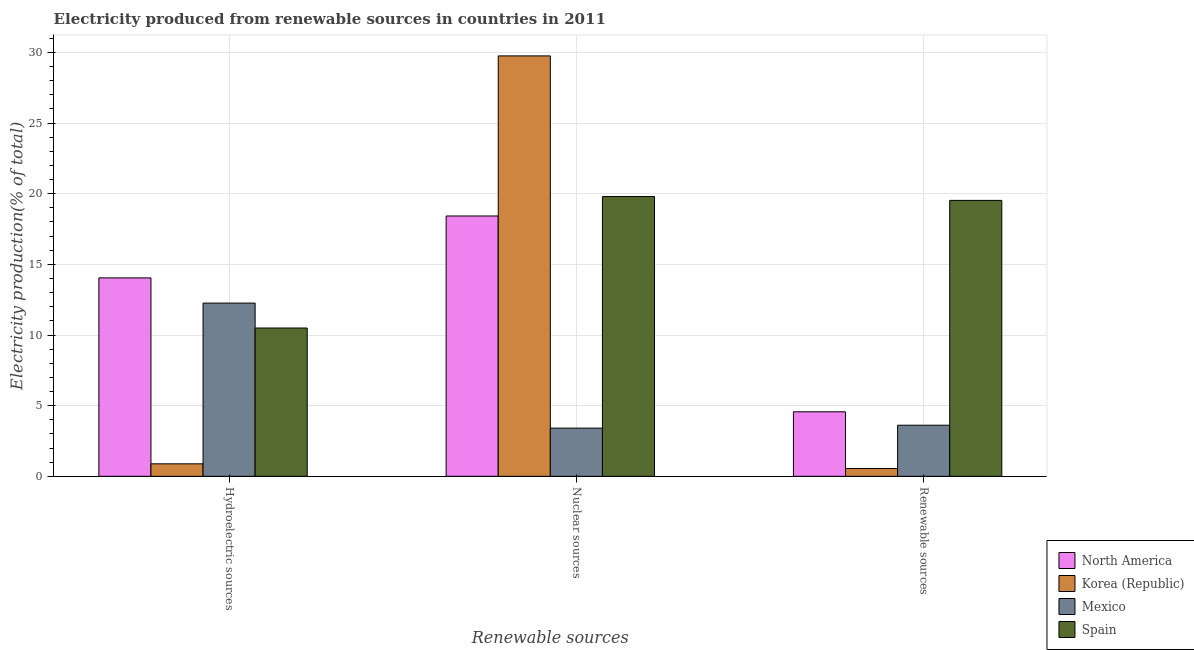Are the number of bars per tick equal to the number of legend labels?
Offer a terse response. Yes. How many bars are there on the 2nd tick from the right?
Give a very brief answer. 4. What is the label of the 1st group of bars from the left?
Provide a short and direct response. Hydroelectric sources. What is the percentage of electricity produced by hydroelectric sources in North America?
Offer a very short reply. 14.04. Across all countries, what is the maximum percentage of electricity produced by renewable sources?
Your response must be concise. 19.53. Across all countries, what is the minimum percentage of electricity produced by nuclear sources?
Your answer should be very brief. 3.41. In which country was the percentage of electricity produced by hydroelectric sources maximum?
Your answer should be compact. North America. In which country was the percentage of electricity produced by nuclear sources minimum?
Your answer should be very brief. Mexico. What is the total percentage of electricity produced by renewable sources in the graph?
Your answer should be very brief. 28.26. What is the difference between the percentage of electricity produced by nuclear sources in North America and that in Korea (Republic)?
Make the answer very short. -11.33. What is the difference between the percentage of electricity produced by renewable sources in Spain and the percentage of electricity produced by nuclear sources in North America?
Make the answer very short. 1.1. What is the average percentage of electricity produced by renewable sources per country?
Your response must be concise. 7.07. What is the difference between the percentage of electricity produced by renewable sources and percentage of electricity produced by nuclear sources in Spain?
Offer a terse response. -0.27. What is the ratio of the percentage of electricity produced by hydroelectric sources in North America to that in Spain?
Provide a short and direct response. 1.34. Is the percentage of electricity produced by hydroelectric sources in Mexico less than that in Korea (Republic)?
Ensure brevity in your answer.  No. Is the difference between the percentage of electricity produced by nuclear sources in North America and Spain greater than the difference between the percentage of electricity produced by hydroelectric sources in North America and Spain?
Your answer should be compact. No. What is the difference between the highest and the second highest percentage of electricity produced by renewable sources?
Provide a short and direct response. 14.96. What is the difference between the highest and the lowest percentage of electricity produced by hydroelectric sources?
Ensure brevity in your answer.  13.16. What does the 2nd bar from the left in Nuclear sources represents?
Make the answer very short. Korea (Republic). What is the difference between two consecutive major ticks on the Y-axis?
Your response must be concise. 5. Are the values on the major ticks of Y-axis written in scientific E-notation?
Your answer should be very brief. No. How many legend labels are there?
Give a very brief answer. 4. What is the title of the graph?
Offer a terse response. Electricity produced from renewable sources in countries in 2011. What is the label or title of the X-axis?
Provide a short and direct response. Renewable sources. What is the Electricity production(% of total) in North America in Hydroelectric sources?
Offer a very short reply. 14.04. What is the Electricity production(% of total) of Korea (Republic) in Hydroelectric sources?
Your answer should be compact. 0.88. What is the Electricity production(% of total) in Mexico in Hydroelectric sources?
Your answer should be compact. 12.26. What is the Electricity production(% of total) of Spain in Hydroelectric sources?
Your answer should be compact. 10.49. What is the Electricity production(% of total) in North America in Nuclear sources?
Give a very brief answer. 18.42. What is the Electricity production(% of total) of Korea (Republic) in Nuclear sources?
Offer a terse response. 29.75. What is the Electricity production(% of total) in Mexico in Nuclear sources?
Keep it short and to the point. 3.41. What is the Electricity production(% of total) of Spain in Nuclear sources?
Your response must be concise. 19.8. What is the Electricity production(% of total) of North America in Renewable sources?
Provide a short and direct response. 4.56. What is the Electricity production(% of total) in Korea (Republic) in Renewable sources?
Ensure brevity in your answer.  0.55. What is the Electricity production(% of total) of Mexico in Renewable sources?
Your answer should be very brief. 3.62. What is the Electricity production(% of total) of Spain in Renewable sources?
Make the answer very short. 19.53. Across all Renewable sources, what is the maximum Electricity production(% of total) in North America?
Ensure brevity in your answer.  18.42. Across all Renewable sources, what is the maximum Electricity production(% of total) in Korea (Republic)?
Offer a terse response. 29.75. Across all Renewable sources, what is the maximum Electricity production(% of total) of Mexico?
Provide a short and direct response. 12.26. Across all Renewable sources, what is the maximum Electricity production(% of total) of Spain?
Offer a terse response. 19.8. Across all Renewable sources, what is the minimum Electricity production(% of total) in North America?
Offer a terse response. 4.56. Across all Renewable sources, what is the minimum Electricity production(% of total) of Korea (Republic)?
Offer a very short reply. 0.55. Across all Renewable sources, what is the minimum Electricity production(% of total) in Mexico?
Provide a succinct answer. 3.41. Across all Renewable sources, what is the minimum Electricity production(% of total) in Spain?
Give a very brief answer. 10.49. What is the total Electricity production(% of total) of North America in the graph?
Give a very brief answer. 37.03. What is the total Electricity production(% of total) of Korea (Republic) in the graph?
Give a very brief answer. 31.19. What is the total Electricity production(% of total) of Mexico in the graph?
Give a very brief answer. 19.29. What is the total Electricity production(% of total) in Spain in the graph?
Keep it short and to the point. 49.82. What is the difference between the Electricity production(% of total) in North America in Hydroelectric sources and that in Nuclear sources?
Make the answer very short. -4.38. What is the difference between the Electricity production(% of total) of Korea (Republic) in Hydroelectric sources and that in Nuclear sources?
Your response must be concise. -28.87. What is the difference between the Electricity production(% of total) of Mexico in Hydroelectric sources and that in Nuclear sources?
Ensure brevity in your answer.  8.85. What is the difference between the Electricity production(% of total) in Spain in Hydroelectric sources and that in Nuclear sources?
Make the answer very short. -9.3. What is the difference between the Electricity production(% of total) in North America in Hydroelectric sources and that in Renewable sources?
Make the answer very short. 9.48. What is the difference between the Electricity production(% of total) in Korea (Republic) in Hydroelectric sources and that in Renewable sources?
Offer a very short reply. 0.33. What is the difference between the Electricity production(% of total) of Mexico in Hydroelectric sources and that in Renewable sources?
Provide a short and direct response. 8.64. What is the difference between the Electricity production(% of total) of Spain in Hydroelectric sources and that in Renewable sources?
Ensure brevity in your answer.  -9.03. What is the difference between the Electricity production(% of total) in North America in Nuclear sources and that in Renewable sources?
Offer a terse response. 13.86. What is the difference between the Electricity production(% of total) of Korea (Republic) in Nuclear sources and that in Renewable sources?
Make the answer very short. 29.2. What is the difference between the Electricity production(% of total) of Mexico in Nuclear sources and that in Renewable sources?
Provide a short and direct response. -0.21. What is the difference between the Electricity production(% of total) of Spain in Nuclear sources and that in Renewable sources?
Give a very brief answer. 0.27. What is the difference between the Electricity production(% of total) in North America in Hydroelectric sources and the Electricity production(% of total) in Korea (Republic) in Nuclear sources?
Offer a terse response. -15.71. What is the difference between the Electricity production(% of total) in North America in Hydroelectric sources and the Electricity production(% of total) in Mexico in Nuclear sources?
Give a very brief answer. 10.63. What is the difference between the Electricity production(% of total) in North America in Hydroelectric sources and the Electricity production(% of total) in Spain in Nuclear sources?
Your response must be concise. -5.76. What is the difference between the Electricity production(% of total) of Korea (Republic) in Hydroelectric sources and the Electricity production(% of total) of Mexico in Nuclear sources?
Your answer should be compact. -2.53. What is the difference between the Electricity production(% of total) of Korea (Republic) in Hydroelectric sources and the Electricity production(% of total) of Spain in Nuclear sources?
Ensure brevity in your answer.  -18.91. What is the difference between the Electricity production(% of total) in Mexico in Hydroelectric sources and the Electricity production(% of total) in Spain in Nuclear sources?
Your answer should be compact. -7.54. What is the difference between the Electricity production(% of total) in North America in Hydroelectric sources and the Electricity production(% of total) in Korea (Republic) in Renewable sources?
Your answer should be compact. 13.49. What is the difference between the Electricity production(% of total) in North America in Hydroelectric sources and the Electricity production(% of total) in Mexico in Renewable sources?
Offer a terse response. 10.43. What is the difference between the Electricity production(% of total) in North America in Hydroelectric sources and the Electricity production(% of total) in Spain in Renewable sources?
Your answer should be compact. -5.48. What is the difference between the Electricity production(% of total) in Korea (Republic) in Hydroelectric sources and the Electricity production(% of total) in Mexico in Renewable sources?
Provide a short and direct response. -2.73. What is the difference between the Electricity production(% of total) of Korea (Republic) in Hydroelectric sources and the Electricity production(% of total) of Spain in Renewable sources?
Give a very brief answer. -18.64. What is the difference between the Electricity production(% of total) in Mexico in Hydroelectric sources and the Electricity production(% of total) in Spain in Renewable sources?
Your answer should be compact. -7.27. What is the difference between the Electricity production(% of total) of North America in Nuclear sources and the Electricity production(% of total) of Korea (Republic) in Renewable sources?
Keep it short and to the point. 17.87. What is the difference between the Electricity production(% of total) in North America in Nuclear sources and the Electricity production(% of total) in Mexico in Renewable sources?
Keep it short and to the point. 14.81. What is the difference between the Electricity production(% of total) in North America in Nuclear sources and the Electricity production(% of total) in Spain in Renewable sources?
Your response must be concise. -1.1. What is the difference between the Electricity production(% of total) of Korea (Republic) in Nuclear sources and the Electricity production(% of total) of Mexico in Renewable sources?
Ensure brevity in your answer.  26.14. What is the difference between the Electricity production(% of total) of Korea (Republic) in Nuclear sources and the Electricity production(% of total) of Spain in Renewable sources?
Make the answer very short. 10.22. What is the difference between the Electricity production(% of total) in Mexico in Nuclear sources and the Electricity production(% of total) in Spain in Renewable sources?
Keep it short and to the point. -16.12. What is the average Electricity production(% of total) of North America per Renewable sources?
Ensure brevity in your answer.  12.34. What is the average Electricity production(% of total) of Korea (Republic) per Renewable sources?
Your answer should be compact. 10.4. What is the average Electricity production(% of total) of Mexico per Renewable sources?
Your answer should be very brief. 6.43. What is the average Electricity production(% of total) in Spain per Renewable sources?
Give a very brief answer. 16.61. What is the difference between the Electricity production(% of total) of North America and Electricity production(% of total) of Korea (Republic) in Hydroelectric sources?
Offer a very short reply. 13.16. What is the difference between the Electricity production(% of total) of North America and Electricity production(% of total) of Mexico in Hydroelectric sources?
Your answer should be very brief. 1.78. What is the difference between the Electricity production(% of total) in North America and Electricity production(% of total) in Spain in Hydroelectric sources?
Your answer should be compact. 3.55. What is the difference between the Electricity production(% of total) in Korea (Republic) and Electricity production(% of total) in Mexico in Hydroelectric sources?
Keep it short and to the point. -11.37. What is the difference between the Electricity production(% of total) of Korea (Republic) and Electricity production(% of total) of Spain in Hydroelectric sources?
Your answer should be compact. -9.61. What is the difference between the Electricity production(% of total) in Mexico and Electricity production(% of total) in Spain in Hydroelectric sources?
Keep it short and to the point. 1.76. What is the difference between the Electricity production(% of total) in North America and Electricity production(% of total) in Korea (Republic) in Nuclear sources?
Offer a very short reply. -11.33. What is the difference between the Electricity production(% of total) of North America and Electricity production(% of total) of Mexico in Nuclear sources?
Make the answer very short. 15.01. What is the difference between the Electricity production(% of total) in North America and Electricity production(% of total) in Spain in Nuclear sources?
Make the answer very short. -1.38. What is the difference between the Electricity production(% of total) of Korea (Republic) and Electricity production(% of total) of Mexico in Nuclear sources?
Give a very brief answer. 26.34. What is the difference between the Electricity production(% of total) in Korea (Republic) and Electricity production(% of total) in Spain in Nuclear sources?
Your answer should be compact. 9.95. What is the difference between the Electricity production(% of total) of Mexico and Electricity production(% of total) of Spain in Nuclear sources?
Give a very brief answer. -16.39. What is the difference between the Electricity production(% of total) in North America and Electricity production(% of total) in Korea (Republic) in Renewable sources?
Your answer should be compact. 4.01. What is the difference between the Electricity production(% of total) of North America and Electricity production(% of total) of Mexico in Renewable sources?
Your answer should be compact. 0.95. What is the difference between the Electricity production(% of total) in North America and Electricity production(% of total) in Spain in Renewable sources?
Your response must be concise. -14.96. What is the difference between the Electricity production(% of total) in Korea (Republic) and Electricity production(% of total) in Mexico in Renewable sources?
Keep it short and to the point. -3.06. What is the difference between the Electricity production(% of total) in Korea (Republic) and Electricity production(% of total) in Spain in Renewable sources?
Offer a very short reply. -18.97. What is the difference between the Electricity production(% of total) in Mexico and Electricity production(% of total) in Spain in Renewable sources?
Keep it short and to the point. -15.91. What is the ratio of the Electricity production(% of total) in North America in Hydroelectric sources to that in Nuclear sources?
Your answer should be compact. 0.76. What is the ratio of the Electricity production(% of total) in Korea (Republic) in Hydroelectric sources to that in Nuclear sources?
Offer a very short reply. 0.03. What is the ratio of the Electricity production(% of total) of Mexico in Hydroelectric sources to that in Nuclear sources?
Ensure brevity in your answer.  3.59. What is the ratio of the Electricity production(% of total) in Spain in Hydroelectric sources to that in Nuclear sources?
Give a very brief answer. 0.53. What is the ratio of the Electricity production(% of total) in North America in Hydroelectric sources to that in Renewable sources?
Offer a terse response. 3.08. What is the ratio of the Electricity production(% of total) in Korea (Republic) in Hydroelectric sources to that in Renewable sources?
Ensure brevity in your answer.  1.6. What is the ratio of the Electricity production(% of total) in Mexico in Hydroelectric sources to that in Renewable sources?
Your response must be concise. 3.39. What is the ratio of the Electricity production(% of total) in Spain in Hydroelectric sources to that in Renewable sources?
Ensure brevity in your answer.  0.54. What is the ratio of the Electricity production(% of total) in North America in Nuclear sources to that in Renewable sources?
Your answer should be very brief. 4.04. What is the ratio of the Electricity production(% of total) of Korea (Republic) in Nuclear sources to that in Renewable sources?
Provide a succinct answer. 53.7. What is the ratio of the Electricity production(% of total) of Mexico in Nuclear sources to that in Renewable sources?
Ensure brevity in your answer.  0.94. What is the ratio of the Electricity production(% of total) of Spain in Nuclear sources to that in Renewable sources?
Provide a short and direct response. 1.01. What is the difference between the highest and the second highest Electricity production(% of total) in North America?
Keep it short and to the point. 4.38. What is the difference between the highest and the second highest Electricity production(% of total) in Korea (Republic)?
Ensure brevity in your answer.  28.87. What is the difference between the highest and the second highest Electricity production(% of total) in Mexico?
Make the answer very short. 8.64. What is the difference between the highest and the second highest Electricity production(% of total) of Spain?
Keep it short and to the point. 0.27. What is the difference between the highest and the lowest Electricity production(% of total) of North America?
Offer a very short reply. 13.86. What is the difference between the highest and the lowest Electricity production(% of total) of Korea (Republic)?
Offer a terse response. 29.2. What is the difference between the highest and the lowest Electricity production(% of total) in Mexico?
Your answer should be compact. 8.85. What is the difference between the highest and the lowest Electricity production(% of total) in Spain?
Give a very brief answer. 9.3. 